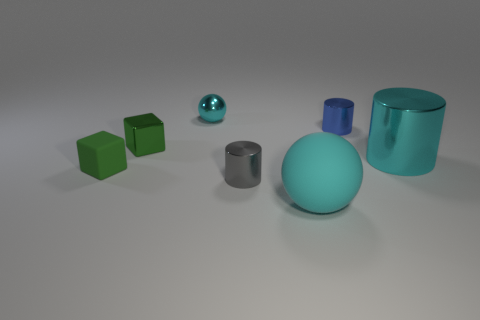Add 2 small spheres. How many objects exist? 9 Subtract all balls. How many objects are left? 5 Subtract all cyan metal spheres. Subtract all small blue metallic objects. How many objects are left? 5 Add 1 big metallic cylinders. How many big metallic cylinders are left? 2 Add 5 blue cylinders. How many blue cylinders exist? 6 Subtract 0 red blocks. How many objects are left? 7 